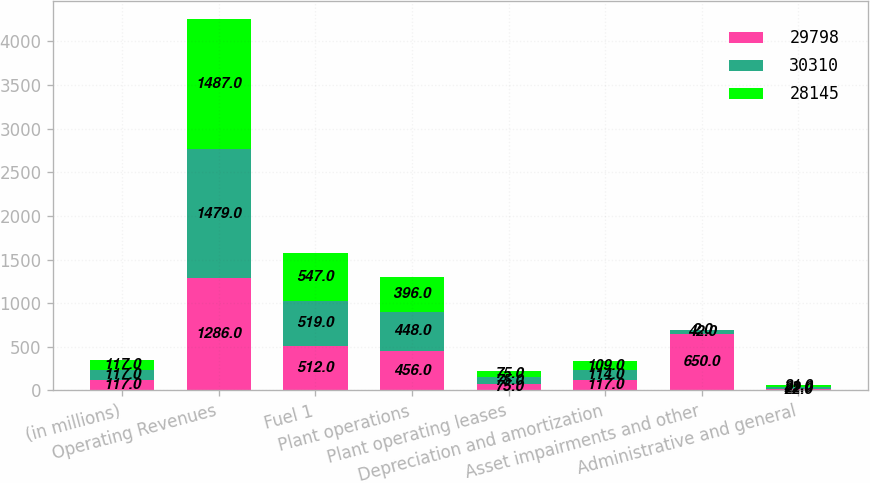Convert chart to OTSL. <chart><loc_0><loc_0><loc_500><loc_500><stacked_bar_chart><ecel><fcel>(in millions)<fcel>Operating Revenues<fcel>Fuel 1<fcel>Plant operations<fcel>Plant operating leases<fcel>Depreciation and amortization<fcel>Asset impairments and other<fcel>Administrative and general<nl><fcel>29798<fcel>117<fcel>1286<fcel>512<fcel>456<fcel>75<fcel>117<fcel>650<fcel>22<nl><fcel>30310<fcel>117<fcel>1479<fcel>519<fcel>448<fcel>75<fcel>114<fcel>42<fcel>22<nl><fcel>28145<fcel>117<fcel>1487<fcel>547<fcel>396<fcel>75<fcel>109<fcel>2<fcel>21<nl></chart> 